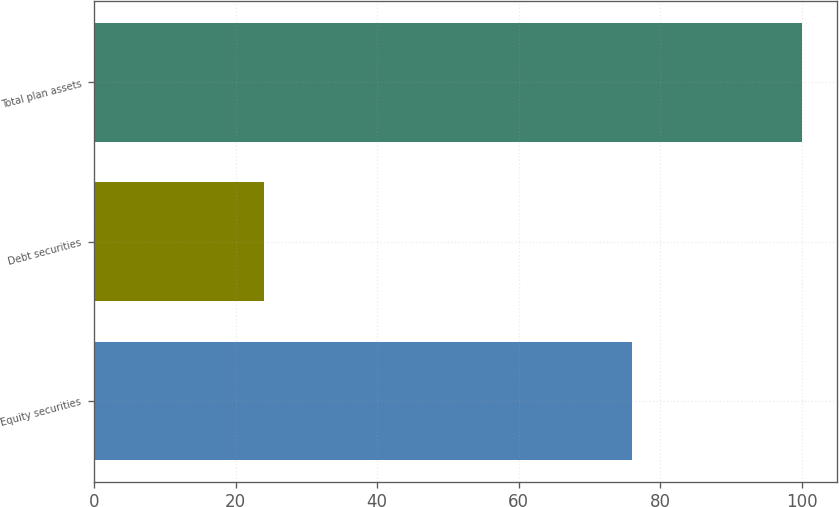Convert chart. <chart><loc_0><loc_0><loc_500><loc_500><bar_chart><fcel>Equity securities<fcel>Debt securities<fcel>Total plan assets<nl><fcel>76<fcel>24<fcel>100<nl></chart> 